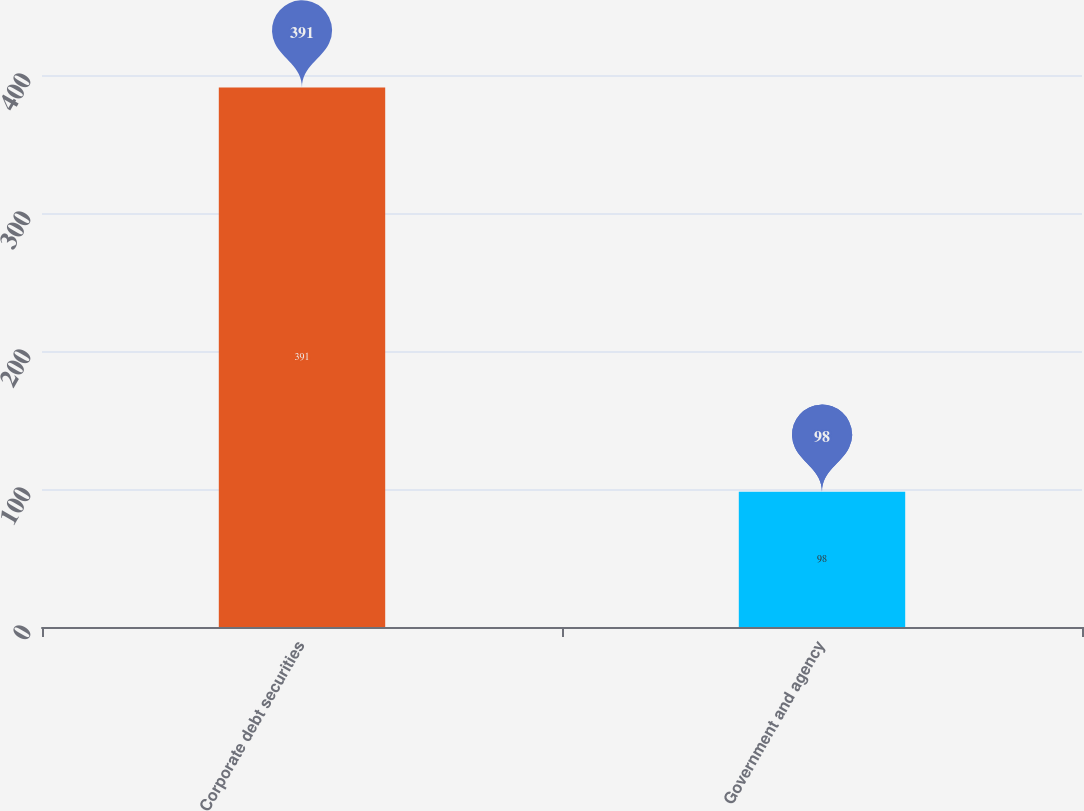<chart> <loc_0><loc_0><loc_500><loc_500><bar_chart><fcel>Corporate debt securities<fcel>Government and agency<nl><fcel>391<fcel>98<nl></chart> 